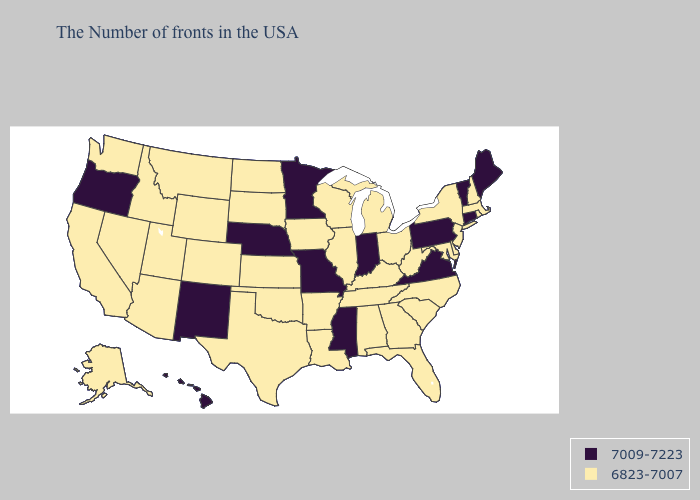What is the highest value in the South ?
Be succinct. 7009-7223. What is the highest value in states that border New Jersey?
Keep it brief. 7009-7223. Does Virginia have the lowest value in the USA?
Answer briefly. No. Which states have the lowest value in the USA?
Quick response, please. Massachusetts, Rhode Island, New Hampshire, New York, New Jersey, Delaware, Maryland, North Carolina, South Carolina, West Virginia, Ohio, Florida, Georgia, Michigan, Kentucky, Alabama, Tennessee, Wisconsin, Illinois, Louisiana, Arkansas, Iowa, Kansas, Oklahoma, Texas, South Dakota, North Dakota, Wyoming, Colorado, Utah, Montana, Arizona, Idaho, Nevada, California, Washington, Alaska. Name the states that have a value in the range 7009-7223?
Be succinct. Maine, Vermont, Connecticut, Pennsylvania, Virginia, Indiana, Mississippi, Missouri, Minnesota, Nebraska, New Mexico, Oregon, Hawaii. Which states hav the highest value in the Northeast?
Short answer required. Maine, Vermont, Connecticut, Pennsylvania. What is the highest value in states that border Texas?
Keep it brief. 7009-7223. Does North Carolina have a lower value than Oregon?
Keep it brief. Yes. Which states have the lowest value in the USA?
Quick response, please. Massachusetts, Rhode Island, New Hampshire, New York, New Jersey, Delaware, Maryland, North Carolina, South Carolina, West Virginia, Ohio, Florida, Georgia, Michigan, Kentucky, Alabama, Tennessee, Wisconsin, Illinois, Louisiana, Arkansas, Iowa, Kansas, Oklahoma, Texas, South Dakota, North Dakota, Wyoming, Colorado, Utah, Montana, Arizona, Idaho, Nevada, California, Washington, Alaska. What is the value of Wisconsin?
Write a very short answer. 6823-7007. What is the value of Virginia?
Quick response, please. 7009-7223. Does Michigan have the lowest value in the MidWest?
Answer briefly. Yes. Name the states that have a value in the range 7009-7223?
Concise answer only. Maine, Vermont, Connecticut, Pennsylvania, Virginia, Indiana, Mississippi, Missouri, Minnesota, Nebraska, New Mexico, Oregon, Hawaii. Name the states that have a value in the range 6823-7007?
Quick response, please. Massachusetts, Rhode Island, New Hampshire, New York, New Jersey, Delaware, Maryland, North Carolina, South Carolina, West Virginia, Ohio, Florida, Georgia, Michigan, Kentucky, Alabama, Tennessee, Wisconsin, Illinois, Louisiana, Arkansas, Iowa, Kansas, Oklahoma, Texas, South Dakota, North Dakota, Wyoming, Colorado, Utah, Montana, Arizona, Idaho, Nevada, California, Washington, Alaska. Does New Mexico have the lowest value in the USA?
Give a very brief answer. No. 